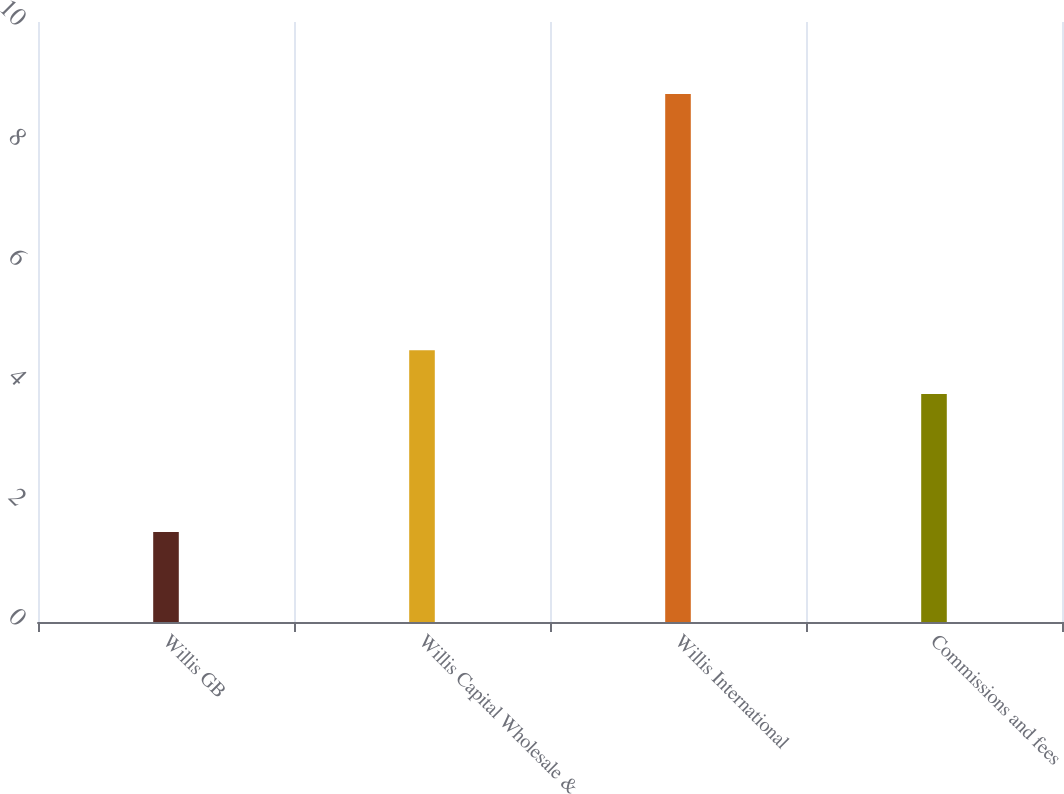<chart> <loc_0><loc_0><loc_500><loc_500><bar_chart><fcel>Willis GB<fcel>Willis Capital Wholesale &<fcel>Willis International<fcel>Commissions and fees<nl><fcel>1.5<fcel>4.53<fcel>8.8<fcel>3.8<nl></chart> 